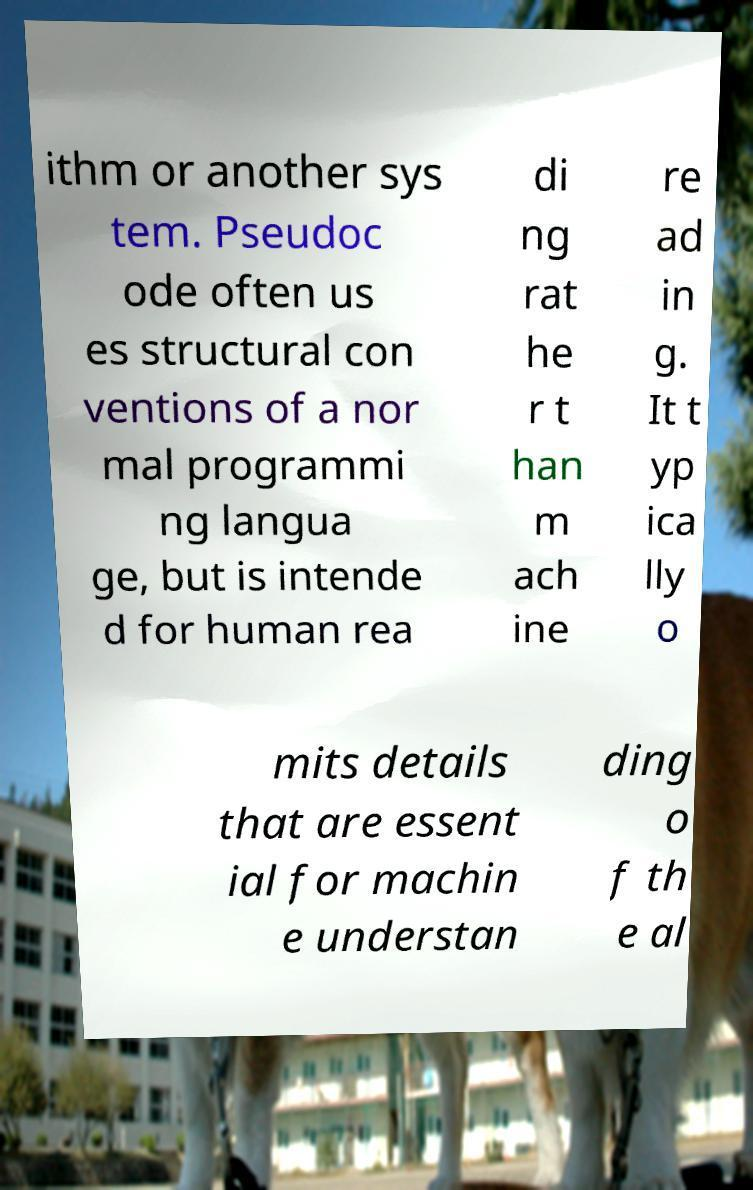For documentation purposes, I need the text within this image transcribed. Could you provide that? ithm or another sys tem. Pseudoc ode often us es structural con ventions of a nor mal programmi ng langua ge, but is intende d for human rea di ng rat he r t han m ach ine re ad in g. It t yp ica lly o mits details that are essent ial for machin e understan ding o f th e al 